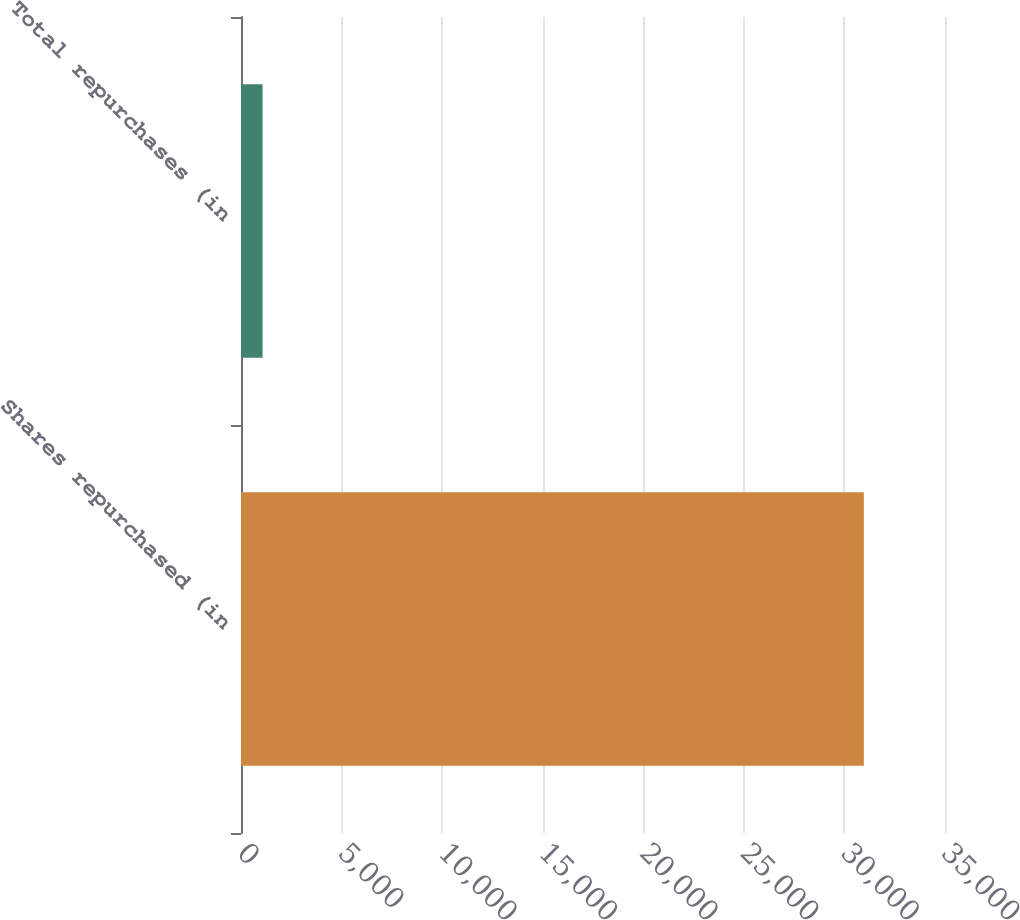<chart> <loc_0><loc_0><loc_500><loc_500><bar_chart><fcel>Shares repurchased (in<fcel>Total repurchases (in<nl><fcel>30965<fcel>1072<nl></chart> 